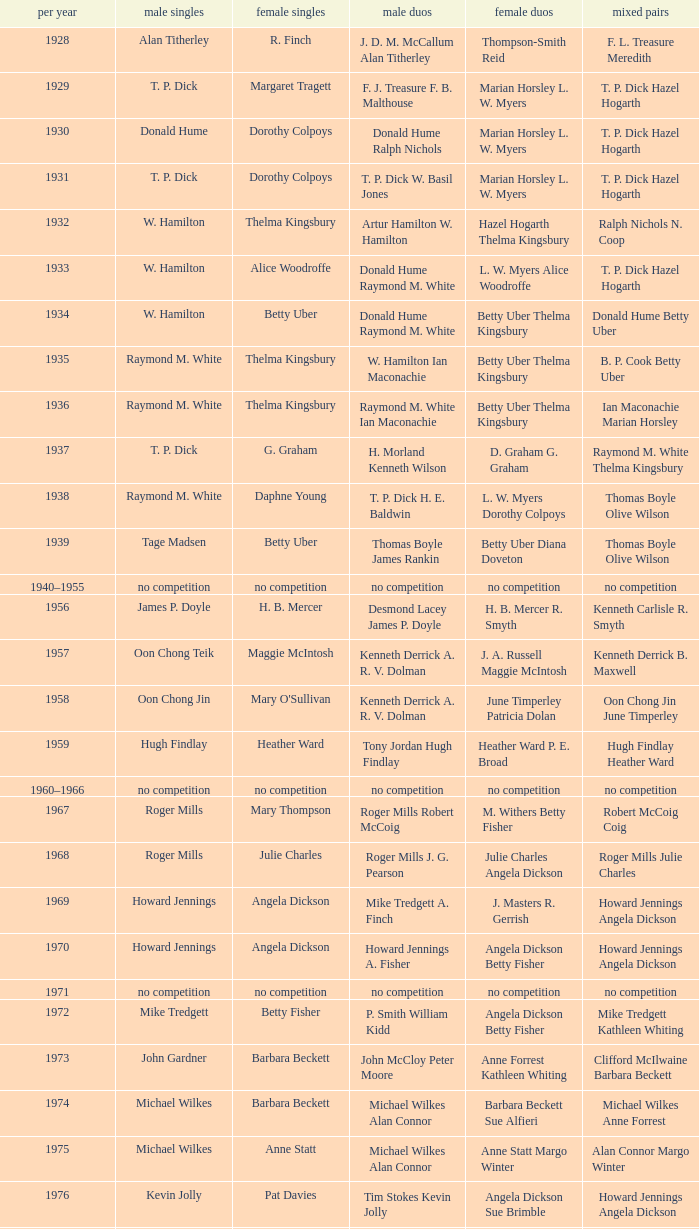Who won the Women's doubles in the year that David Eddy Eddy Sutton won the Men's doubles, and that David Eddy won the Men's singles? Anne Statt Jane Webster. Write the full table. {'header': ['per year', 'male singles', 'female singles', 'male duos', 'female duos', 'mixed pairs'], 'rows': [['1928', 'Alan Titherley', 'R. Finch', 'J. D. M. McCallum Alan Titherley', 'Thompson-Smith Reid', 'F. L. Treasure Meredith'], ['1929', 'T. P. Dick', 'Margaret Tragett', 'F. J. Treasure F. B. Malthouse', 'Marian Horsley L. W. Myers', 'T. P. Dick Hazel Hogarth'], ['1930', 'Donald Hume', 'Dorothy Colpoys', 'Donald Hume Ralph Nichols', 'Marian Horsley L. W. Myers', 'T. P. Dick Hazel Hogarth'], ['1931', 'T. P. Dick', 'Dorothy Colpoys', 'T. P. Dick W. Basil Jones', 'Marian Horsley L. W. Myers', 'T. P. Dick Hazel Hogarth'], ['1932', 'W. Hamilton', 'Thelma Kingsbury', 'Artur Hamilton W. Hamilton', 'Hazel Hogarth Thelma Kingsbury', 'Ralph Nichols N. Coop'], ['1933', 'W. Hamilton', 'Alice Woodroffe', 'Donald Hume Raymond M. White', 'L. W. Myers Alice Woodroffe', 'T. P. Dick Hazel Hogarth'], ['1934', 'W. Hamilton', 'Betty Uber', 'Donald Hume Raymond M. White', 'Betty Uber Thelma Kingsbury', 'Donald Hume Betty Uber'], ['1935', 'Raymond M. White', 'Thelma Kingsbury', 'W. Hamilton Ian Maconachie', 'Betty Uber Thelma Kingsbury', 'B. P. Cook Betty Uber'], ['1936', 'Raymond M. White', 'Thelma Kingsbury', 'Raymond M. White Ian Maconachie', 'Betty Uber Thelma Kingsbury', 'Ian Maconachie Marian Horsley'], ['1937', 'T. P. Dick', 'G. Graham', 'H. Morland Kenneth Wilson', 'D. Graham G. Graham', 'Raymond M. White Thelma Kingsbury'], ['1938', 'Raymond M. White', 'Daphne Young', 'T. P. Dick H. E. Baldwin', 'L. W. Myers Dorothy Colpoys', 'Thomas Boyle Olive Wilson'], ['1939', 'Tage Madsen', 'Betty Uber', 'Thomas Boyle James Rankin', 'Betty Uber Diana Doveton', 'Thomas Boyle Olive Wilson'], ['1940–1955', 'no competition', 'no competition', 'no competition', 'no competition', 'no competition'], ['1956', 'James P. Doyle', 'H. B. Mercer', 'Desmond Lacey James P. Doyle', 'H. B. Mercer R. Smyth', 'Kenneth Carlisle R. Smyth'], ['1957', 'Oon Chong Teik', 'Maggie McIntosh', 'Kenneth Derrick A. R. V. Dolman', 'J. A. Russell Maggie McIntosh', 'Kenneth Derrick B. Maxwell'], ['1958', 'Oon Chong Jin', "Mary O'Sullivan", 'Kenneth Derrick A. R. V. Dolman', 'June Timperley Patricia Dolan', 'Oon Chong Jin June Timperley'], ['1959', 'Hugh Findlay', 'Heather Ward', 'Tony Jordan Hugh Findlay', 'Heather Ward P. E. Broad', 'Hugh Findlay Heather Ward'], ['1960–1966', 'no competition', 'no competition', 'no competition', 'no competition', 'no competition'], ['1967', 'Roger Mills', 'Mary Thompson', 'Roger Mills Robert McCoig', 'M. Withers Betty Fisher', 'Robert McCoig Coig'], ['1968', 'Roger Mills', 'Julie Charles', 'Roger Mills J. G. Pearson', 'Julie Charles Angela Dickson', 'Roger Mills Julie Charles'], ['1969', 'Howard Jennings', 'Angela Dickson', 'Mike Tredgett A. Finch', 'J. Masters R. Gerrish', 'Howard Jennings Angela Dickson'], ['1970', 'Howard Jennings', 'Angela Dickson', 'Howard Jennings A. Fisher', 'Angela Dickson Betty Fisher', 'Howard Jennings Angela Dickson'], ['1971', 'no competition', 'no competition', 'no competition', 'no competition', 'no competition'], ['1972', 'Mike Tredgett', 'Betty Fisher', 'P. Smith William Kidd', 'Angela Dickson Betty Fisher', 'Mike Tredgett Kathleen Whiting'], ['1973', 'John Gardner', 'Barbara Beckett', 'John McCloy Peter Moore', 'Anne Forrest Kathleen Whiting', 'Clifford McIlwaine Barbara Beckett'], ['1974', 'Michael Wilkes', 'Barbara Beckett', 'Michael Wilkes Alan Connor', 'Barbara Beckett Sue Alfieri', 'Michael Wilkes Anne Forrest'], ['1975', 'Michael Wilkes', 'Anne Statt', 'Michael Wilkes Alan Connor', 'Anne Statt Margo Winter', 'Alan Connor Margo Winter'], ['1976', 'Kevin Jolly', 'Pat Davies', 'Tim Stokes Kevin Jolly', 'Angela Dickson Sue Brimble', 'Howard Jennings Angela Dickson'], ['1977', 'David Eddy', 'Paula Kilvington', 'David Eddy Eddy Sutton', 'Anne Statt Jane Webster', 'David Eddy Barbara Giles'], ['1978', 'Mike Tredgett', 'Gillian Gilks', 'David Eddy Eddy Sutton', 'Barbara Sutton Marjan Ridder', 'Elliot Stuart Gillian Gilks'], ['1979', 'Kevin Jolly', 'Nora Perry', 'Ray Stevens Mike Tredgett', 'Barbara Sutton Nora Perry', 'Mike Tredgett Nora Perry'], ['1980', 'Thomas Kihlström', 'Jane Webster', 'Thomas Kihlström Bengt Fröman', 'Jane Webster Karen Puttick', 'Billy Gilliland Karen Puttick'], ['1981', 'Ray Stevens', 'Gillian Gilks', 'Ray Stevens Mike Tredgett', 'Gillian Gilks Paula Kilvington', 'Mike Tredgett Nora Perry'], ['1982', 'Steve Baddeley', 'Karen Bridge', 'David Eddy Eddy Sutton', 'Karen Chapman Sally Podger', 'Billy Gilliland Karen Chapman'], ['1983', 'Steve Butler', 'Sally Podger', 'Mike Tredgett Dipak Tailor', 'Nora Perry Jane Webster', 'Dipak Tailor Nora Perry'], ['1984', 'Steve Butler', 'Karen Beckman', 'Mike Tredgett Martin Dew', 'Helen Troke Karen Chapman', 'Mike Tredgett Karen Chapman'], ['1985', 'Morten Frost', 'Charlotte Hattens', 'Billy Gilliland Dan Travers', 'Gillian Gilks Helen Troke', 'Martin Dew Gillian Gilks'], ['1986', 'Darren Hall', 'Fiona Elliott', 'Martin Dew Dipak Tailor', 'Karen Beckman Sara Halsall', 'Jesper Knudsen Nettie Nielsen'], ['1987', 'Darren Hall', 'Fiona Elliott', 'Martin Dew Darren Hall', 'Karen Beckman Sara Halsall', 'Martin Dew Gillian Gilks'], ['1988', 'Vimal Kumar', 'Lee Jung-mi', 'Richard Outterside Mike Brown', 'Fiona Elliott Sara Halsall', 'Martin Dew Gillian Gilks'], ['1989', 'Darren Hall', 'Bang Soo-hyun', 'Nick Ponting Dave Wright', 'Karen Beckman Sara Sankey', 'Mike Brown Jillian Wallwork'], ['1990', 'Mathew Smith', 'Joanne Muggeridge', 'Nick Ponting Dave Wright', 'Karen Chapman Sara Sankey', 'Dave Wright Claire Palmer'], ['1991', 'Vimal Kumar', 'Denyse Julien', 'Nick Ponting Dave Wright', 'Cheryl Johnson Julie Bradbury', 'Nick Ponting Joanne Wright'], ['1992', 'Wei Yan', 'Fiona Smith', 'Michael Adams Chris Rees', 'Denyse Julien Doris Piché', 'Andy Goode Joanne Wright'], ['1993', 'Anders Nielsen', 'Sue Louis Lane', 'Nick Ponting Dave Wright', 'Julie Bradbury Sara Sankey', 'Nick Ponting Joanne Wright'], ['1994', 'Darren Hall', 'Marina Andrievskaya', 'Michael Adams Simon Archer', 'Julie Bradbury Joanne Wright', 'Chris Hunt Joanne Wright'], ['1995', 'Peter Rasmussen', 'Denyse Julien', 'Andrei Andropov Nikolai Zuyev', 'Julie Bradbury Joanne Wright', 'Nick Ponting Joanne Wright'], ['1996', 'Colin Haughton', 'Elena Rybkina', 'Andrei Andropov Nikolai Zuyev', 'Elena Rybkina Marina Yakusheva', 'Nikolai Zuyev Marina Yakusheva'], ['1997', 'Chris Bruil', 'Kelly Morgan', 'Ian Pearson James Anderson', 'Nicole van Hooren Brenda Conijn', 'Quinten van Dalm Nicole van Hooren'], ['1998', 'Dicky Palyama', 'Brenda Beenhakker', 'James Anderson Ian Sullivan', 'Sara Sankey Ella Tripp', 'James Anderson Sara Sankey'], ['1999', 'Daniel Eriksson', 'Marina Andrievskaya', 'Joachim Tesche Jean-Philippe Goyette', 'Marina Andrievskaya Catrine Bengtsson', 'Henrik Andersson Marina Andrievskaya'], ['2000', 'Richard Vaughan', 'Marina Yakusheva', 'Joachim Andersson Peter Axelsson', 'Irina Ruslyakova Marina Yakusheva', 'Peter Jeffrey Joanne Davies'], ['2001', 'Irwansyah', 'Brenda Beenhakker', 'Vincent Laigle Svetoslav Stoyanov', 'Sara Sankey Ella Tripp', 'Nikolai Zuyev Marina Yakusheva'], ['2002', 'Irwansyah', 'Karina de Wit', 'Nikolai Zuyev Stanislav Pukhov', 'Ella Tripp Joanne Wright', 'Nikolai Zuyev Marina Yakusheva'], ['2003', 'Irwansyah', 'Ella Karachkova', 'Ashley Thilthorpe Kristian Roebuck', 'Ella Karachkova Anastasia Russkikh', 'Alexandr Russkikh Anastasia Russkikh'], ['2004', 'Nathan Rice', 'Petya Nedelcheva', 'Reuben Gordown Aji Basuki Sindoro', 'Petya Nedelcheva Yuan Wemyss', 'Matthew Hughes Kelly Morgan'], ['2005', 'Chetan Anand', 'Eleanor Cox', 'Andrew Ellis Dean George', 'Hayley Connor Heather Olver', 'Valiyaveetil Diju Jwala Gutta'], ['2006', 'Irwansyah', 'Huang Chia-chi', 'Matthew Hughes Martyn Lewis', 'Natalie Munt Mariana Agathangelou', 'Kristian Roebuck Natalie Munt'], ['2007', 'Marc Zwiebler', 'Jill Pittard', 'Wojciech Szkudlarczyk Adam Cwalina', 'Chloe Magee Bing Huang', 'Wojciech Szkudlarczyk Malgorzata Kurdelska'], ['2008', 'Brice Leverdez', 'Kati Tolmoff', 'Andrew Bowman Martyn Lewis', 'Mariana Agathangelou Jillie Cooper', 'Watson Briggs Jillie Cooper'], ['2009', 'Kristian Nielsen', 'Tatjana Bibik', 'Vitaliy Durkin Alexandr Nikolaenko', 'Valeria Sorokina Nina Vislova', 'Vitaliy Durkin Nina Vislova'], ['2010', 'Pablo Abián', 'Anita Raj Kaur', 'Peter Käsbauer Josche Zurwonne', 'Joanne Quay Swee Ling Anita Raj Kaur', 'Peter Käsbauer Johanna Goliszewski'], ['2011', 'Niluka Karunaratne', 'Nicole Schaller', 'Chris Coles Matthew Nottingham', 'Ng Hui Ern Ng Hui Lin', 'Martin Campbell Ng Hui Lin'], ['2012', 'Chou Tien-chen', 'Chiang Mei-hui', 'Marcus Ellis Paul Van Rietvelde', 'Gabrielle White Lauren Smith', 'Marcus Ellis Gabrielle White']]} 